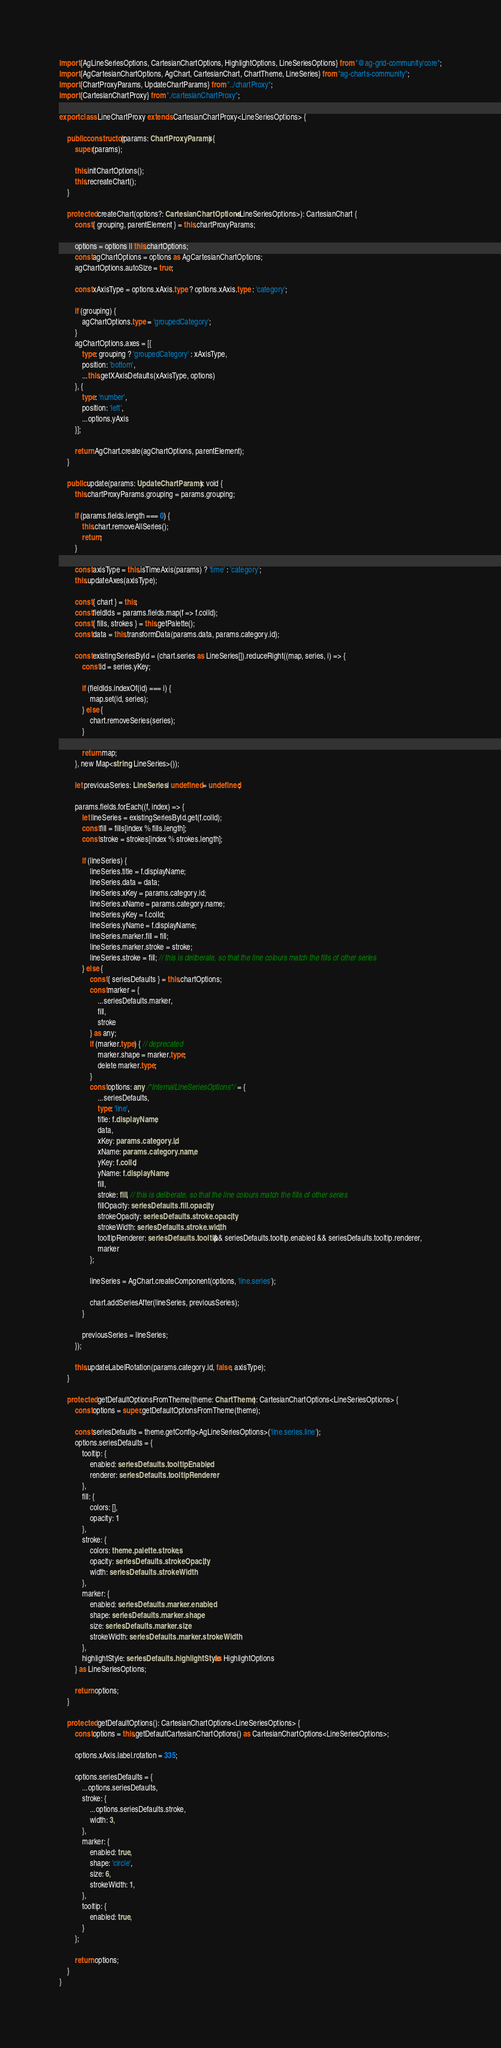Convert code to text. <code><loc_0><loc_0><loc_500><loc_500><_TypeScript_>import {AgLineSeriesOptions, CartesianChartOptions, HighlightOptions, LineSeriesOptions} from "@ag-grid-community/core";
import {AgCartesianChartOptions, AgChart, CartesianChart, ChartTheme, LineSeries} from "ag-charts-community";
import {ChartProxyParams, UpdateChartParams} from "../chartProxy";
import {CartesianChartProxy} from "./cartesianChartProxy";

export class LineChartProxy extends CartesianChartProxy<LineSeriesOptions> {

    public constructor(params: ChartProxyParams) {
        super(params);

        this.initChartOptions();
        this.recreateChart();
    }

    protected createChart(options?: CartesianChartOptions<LineSeriesOptions>): CartesianChart {
        const { grouping, parentElement } = this.chartProxyParams;

        options = options || this.chartOptions;
        const agChartOptions = options as AgCartesianChartOptions;
        agChartOptions.autoSize = true;

        const xAxisType = options.xAxis.type ? options.xAxis.type : 'category';

        if (grouping) {
            agChartOptions.type = 'groupedCategory';
        }
        agChartOptions.axes = [{
            type: grouping ? 'groupedCategory' : xAxisType,
            position: 'bottom',
            ...this.getXAxisDefaults(xAxisType, options)
        }, {
            type: 'number',
            position: 'left',
            ...options.yAxis
        }];

        return AgChart.create(agChartOptions, parentElement);
    }

    public update(params: UpdateChartParams): void {
        this.chartProxyParams.grouping = params.grouping;

        if (params.fields.length === 0) {
            this.chart.removeAllSeries();
            return;
        }

        const axisType = this.isTimeAxis(params) ? 'time' : 'category';
        this.updateAxes(axisType);

        const { chart } = this;
        const fieldIds = params.fields.map(f => f.colId);
        const { fills, strokes } = this.getPalette();
        const data = this.transformData(params.data, params.category.id);

        const existingSeriesById = (chart.series as LineSeries[]).reduceRight((map, series, i) => {
            const id = series.yKey;

            if (fieldIds.indexOf(id) === i) {
                map.set(id, series);
            } else {
                chart.removeSeries(series);
            }

            return map;
        }, new Map<string, LineSeries>());

        let previousSeries: LineSeries | undefined = undefined;

        params.fields.forEach((f, index) => {
            let lineSeries = existingSeriesById.get(f.colId);
            const fill = fills[index % fills.length];
            const stroke = strokes[index % strokes.length];

            if (lineSeries) {
                lineSeries.title = f.displayName;
                lineSeries.data = data;
                lineSeries.xKey = params.category.id;
                lineSeries.xName = params.category.name;
                lineSeries.yKey = f.colId;
                lineSeries.yName = f.displayName;
                lineSeries.marker.fill = fill;
                lineSeries.marker.stroke = stroke;
                lineSeries.stroke = fill; // this is deliberate, so that the line colours match the fills of other series
            } else {
                const { seriesDefaults } = this.chartOptions;
                const marker = {
                    ...seriesDefaults.marker,
                    fill,
                    stroke
                } as any;
                if (marker.type) { // deprecated
                    marker.shape = marker.type;
                    delete marker.type;
                }
                const options: any /*InternalLineSeriesOptions*/ = {
                    ...seriesDefaults,
                    type: 'line',
                    title: f.displayName,
                    data,
                    xKey: params.category.id,
                    xName: params.category.name,
                    yKey: f.colId,
                    yName: f.displayName,
                    fill,
                    stroke: fill, // this is deliberate, so that the line colours match the fills of other series
                    fillOpacity: seriesDefaults.fill.opacity,
                    strokeOpacity: seriesDefaults.stroke.opacity,
                    strokeWidth: seriesDefaults.stroke.width,
                    tooltipRenderer: seriesDefaults.tooltip && seriesDefaults.tooltip.enabled && seriesDefaults.tooltip.renderer,
                    marker
                };

                lineSeries = AgChart.createComponent(options, 'line.series');

                chart.addSeriesAfter(lineSeries, previousSeries);
            }

            previousSeries = lineSeries;
        });

        this.updateLabelRotation(params.category.id, false, axisType);
    }

    protected getDefaultOptionsFromTheme(theme: ChartTheme): CartesianChartOptions<LineSeriesOptions> {
        const options = super.getDefaultOptionsFromTheme(theme);

        const seriesDefaults = theme.getConfig<AgLineSeriesOptions>('line.series.line');
        options.seriesDefaults = {
            tooltip: {
                enabled: seriesDefaults.tooltipEnabled,
                renderer: seriesDefaults.tooltipRenderer
            },
            fill: {
                colors: [],
                opacity: 1
            },
            stroke: {
                colors: theme.palette.strokes,
                opacity: seriesDefaults.strokeOpacity,
                width: seriesDefaults.strokeWidth
            },
            marker: {
                enabled: seriesDefaults.marker.enabled,
                shape: seriesDefaults.marker.shape,
                size: seriesDefaults.marker.size,
                strokeWidth: seriesDefaults.marker.strokeWidth
            },
            highlightStyle: seriesDefaults.highlightStyle as HighlightOptions
        } as LineSeriesOptions;

        return options;
    }

    protected getDefaultOptions(): CartesianChartOptions<LineSeriesOptions> {
        const options = this.getDefaultCartesianChartOptions() as CartesianChartOptions<LineSeriesOptions>;

        options.xAxis.label.rotation = 335;

        options.seriesDefaults = {
            ...options.seriesDefaults,
            stroke: {
                ...options.seriesDefaults.stroke,
                width: 3,
            },
            marker: {
                enabled: true,
                shape: 'circle',
                size: 6,
                strokeWidth: 1,
            },
            tooltip: {
                enabled: true,
            }
        };

        return options;
    }
}</code> 